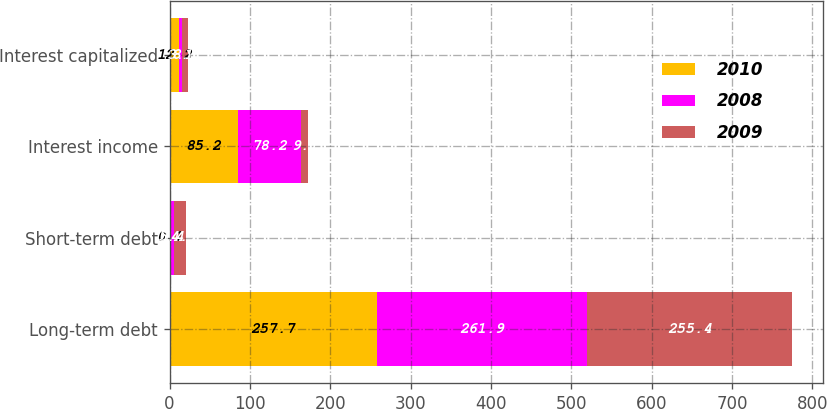Convert chart to OTSL. <chart><loc_0><loc_0><loc_500><loc_500><stacked_bar_chart><ecel><fcel>Long-term debt<fcel>Short-term debt<fcel>Interest income<fcel>Interest capitalized<nl><fcel>2010<fcel>257.7<fcel>0.1<fcel>85.2<fcel>12.2<nl><fcel>2008<fcel>261.9<fcel>5.4<fcel>78.2<fcel>3.1<nl><fcel>2009<fcel>255.4<fcel>14.7<fcel>9.1<fcel>8.1<nl></chart> 